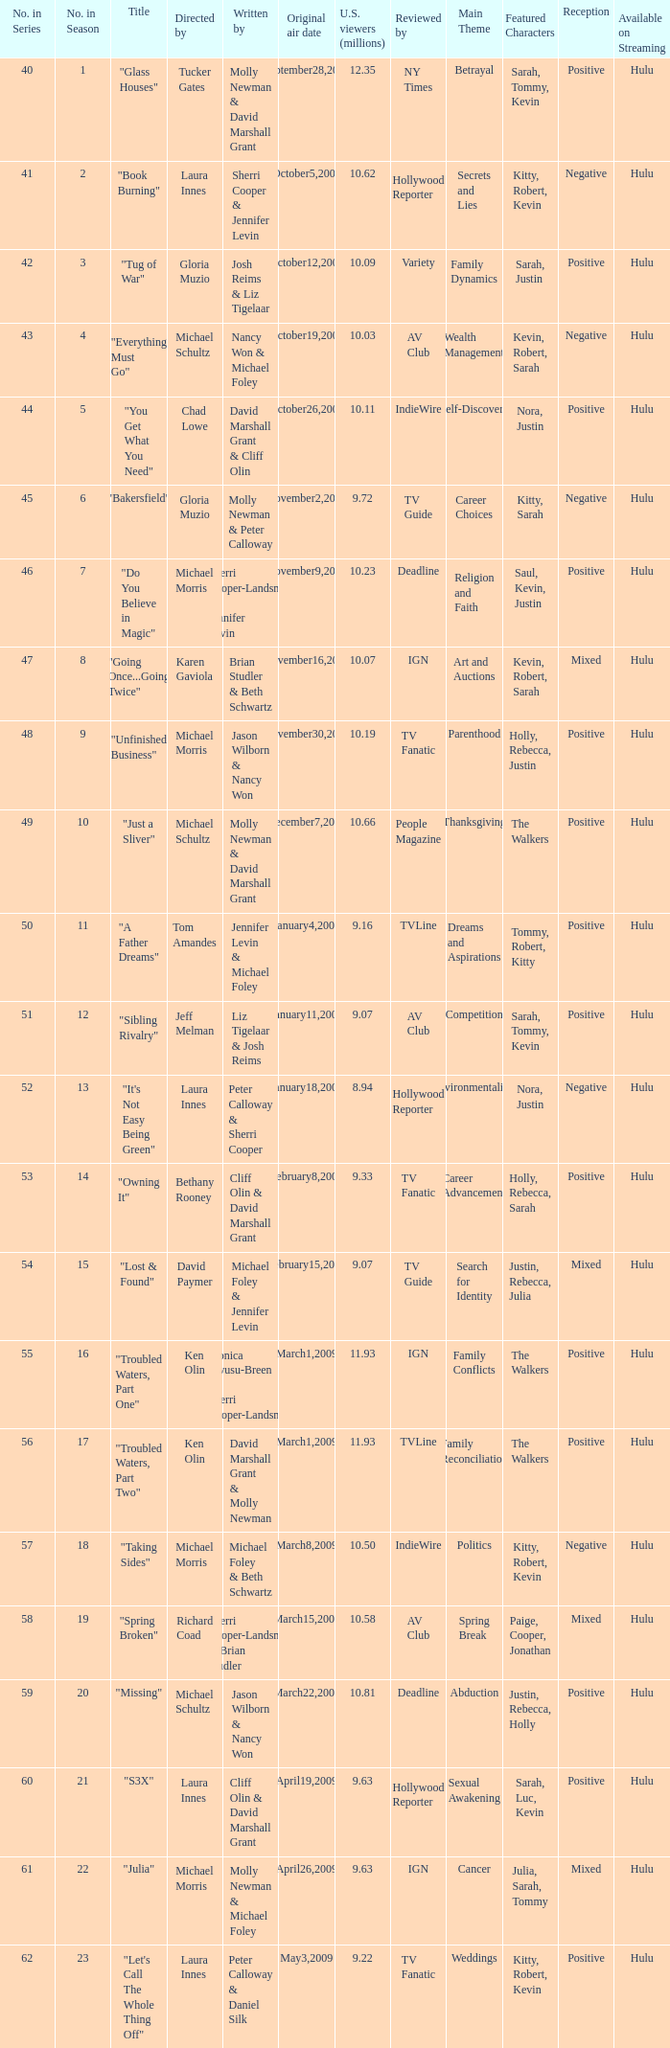When did the episode viewed by 10.50 millions of people in the US run for the first time? March8,2009. 